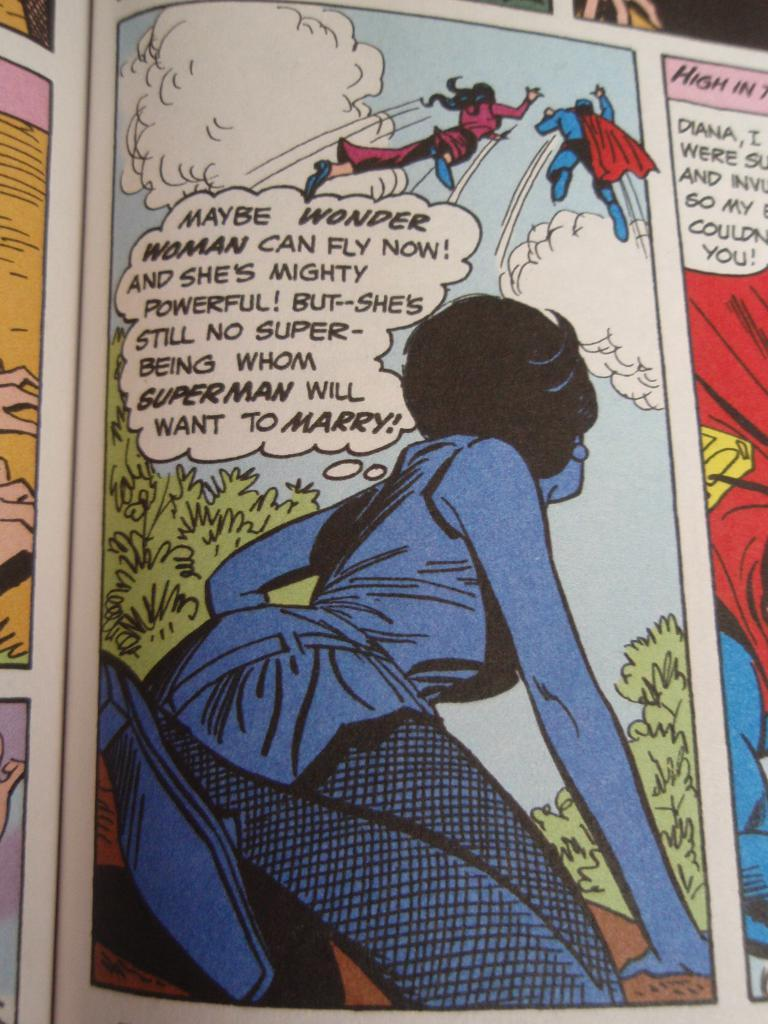What type of book is in the picture? There is a comic book in the picture. What kind of characters are depicted in the picture? There are cartoon characters in the picture. What can be seen in the sky in the picture? There are clouds in the sky in the picture. What type of vegetation is in the picture? There are trees in the picture. What type of writing is in the picture? There are texts in the picture. What holiday is being celebrated in the picture? There is no indication of a holiday being celebrated in the picture. Is it raining in the picture? There is no mention of rain in the picture; only clouds are visible in the sky. 